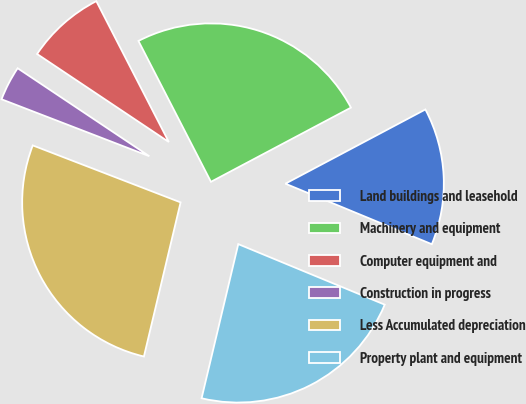Convert chart. <chart><loc_0><loc_0><loc_500><loc_500><pie_chart><fcel>Land buildings and leasehold<fcel>Machinery and equipment<fcel>Computer equipment and<fcel>Construction in progress<fcel>Less Accumulated depreciation<fcel>Property plant and equipment<nl><fcel>14.0%<fcel>24.81%<fcel>8.06%<fcel>3.52%<fcel>27.14%<fcel>22.48%<nl></chart> 